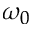<formula> <loc_0><loc_0><loc_500><loc_500>\omega _ { 0 }</formula> 